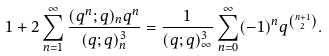Convert formula to latex. <formula><loc_0><loc_0><loc_500><loc_500>1 + 2 \sum _ { n = 1 } ^ { \infty } \frac { ( q ^ { n } ; q ) _ { n } q ^ { n } } { ( q ; q ) ^ { 3 } _ { n } } = \frac { 1 } { ( q ; q ) ^ { 3 } _ { \infty } } \sum _ { n = 0 } ^ { \infty } ( - 1 ) ^ { n } q ^ { \binom { n + 1 } { 2 } } .</formula> 